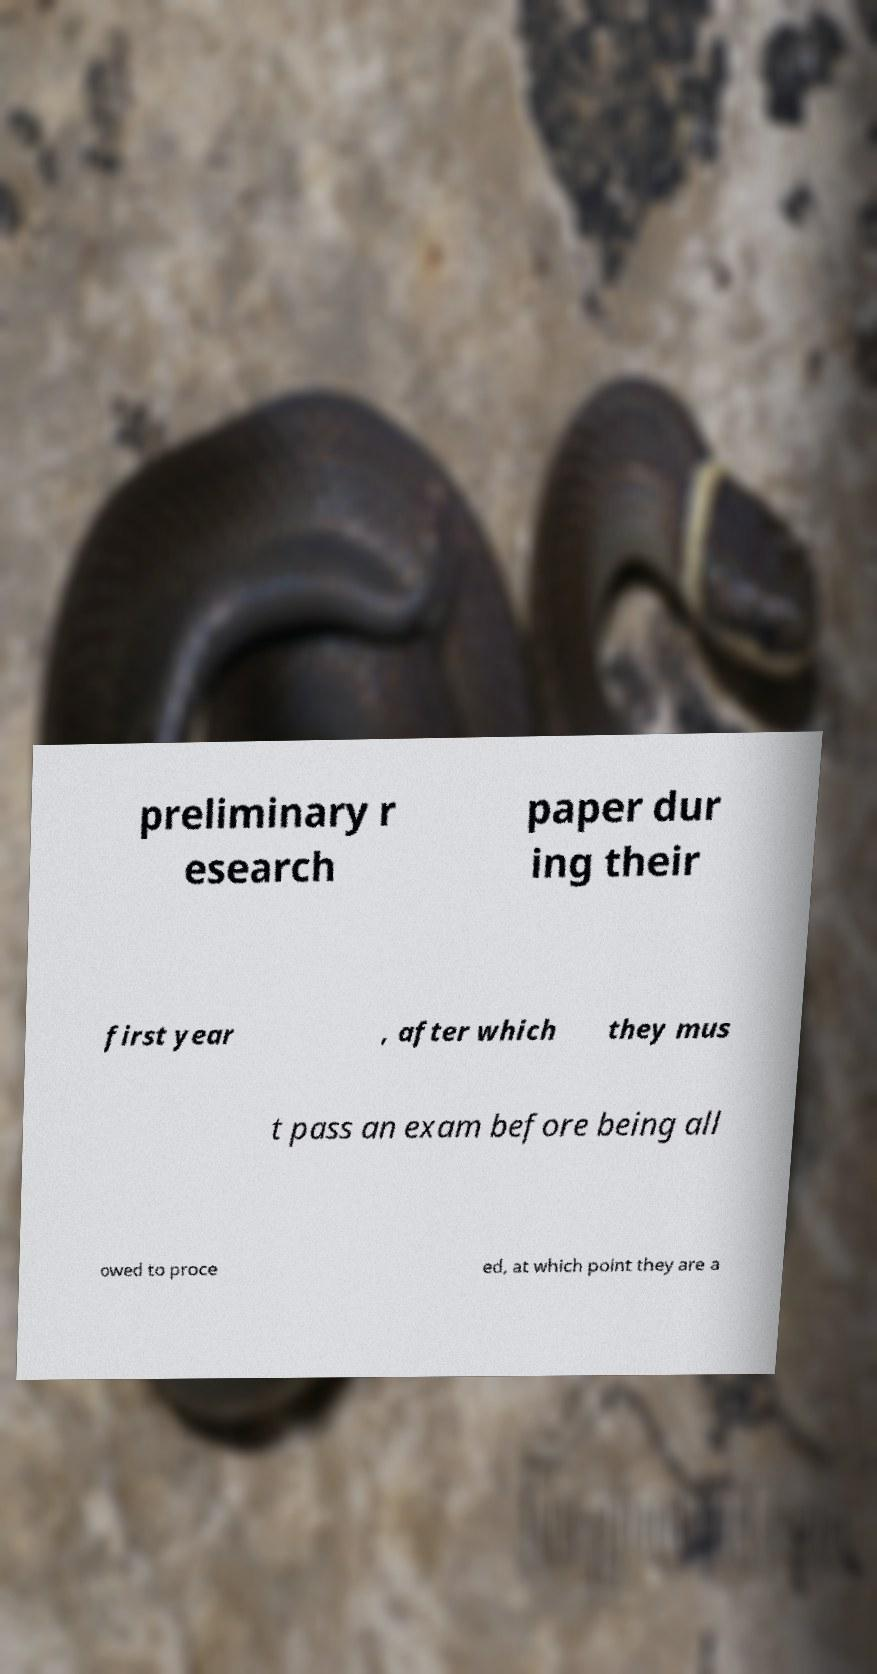I need the written content from this picture converted into text. Can you do that? preliminary r esearch paper dur ing their first year , after which they mus t pass an exam before being all owed to proce ed, at which point they are a 